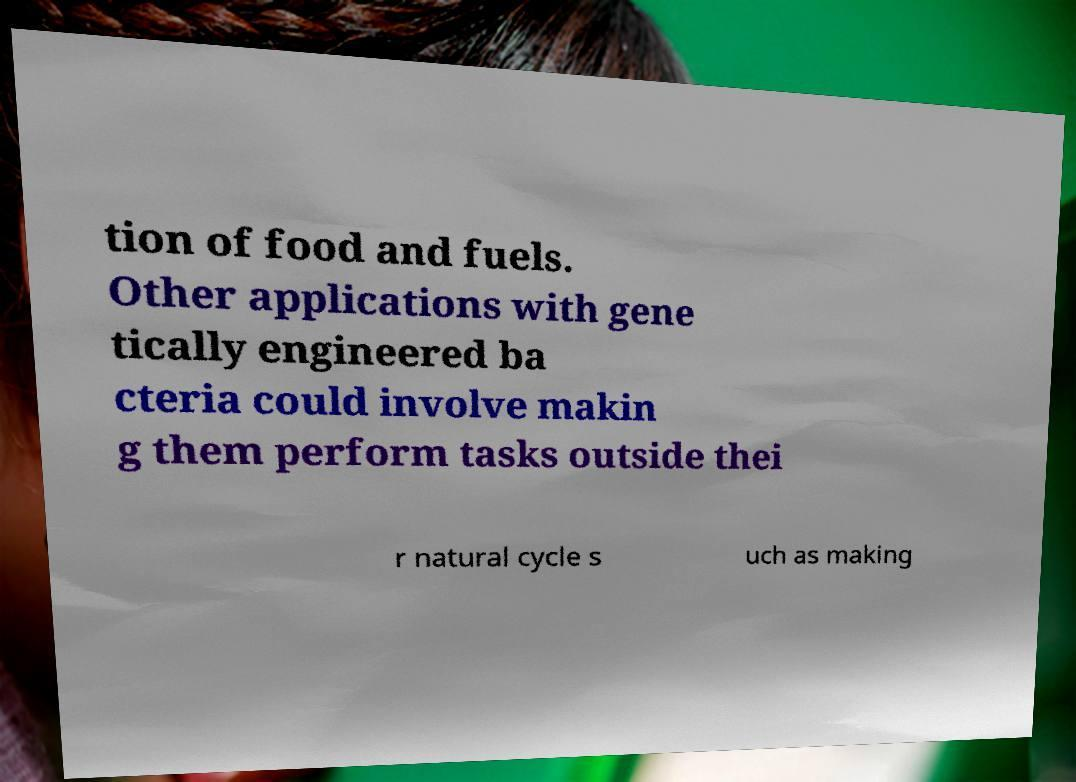Please identify and transcribe the text found in this image. tion of food and fuels. Other applications with gene tically engineered ba cteria could involve makin g them perform tasks outside thei r natural cycle s uch as making 